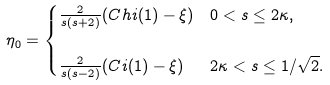Convert formula to latex. <formula><loc_0><loc_0><loc_500><loc_500>\eta _ { 0 } & = \begin{cases} \frac { 2 } { s ( s + 2 ) } ( C h i ( 1 ) - \xi ) & 0 < s \leq 2 \kappa , \\ & \\ \frac { 2 } { s ( s - 2 ) } ( C i ( 1 ) - \xi ) & 2 \kappa < s \leq 1 / \sqrt { 2 } . \end{cases}</formula> 